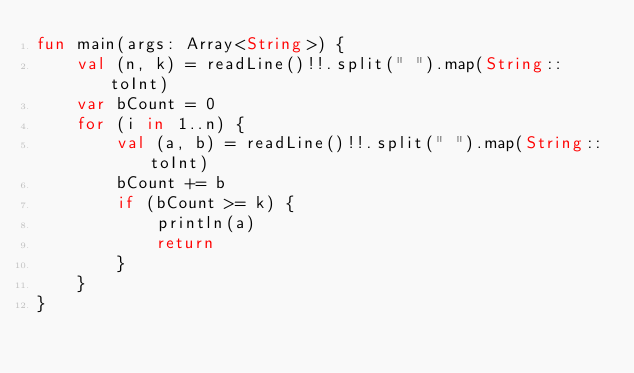Convert code to text. <code><loc_0><loc_0><loc_500><loc_500><_Kotlin_>fun main(args: Array<String>) {
    val (n, k) = readLine()!!.split(" ").map(String::toInt)
    var bCount = 0
    for (i in 1..n) {
        val (a, b) = readLine()!!.split(" ").map(String::toInt)
        bCount += b
        if (bCount >= k) {
            println(a)
            return
        }
    }
}</code> 